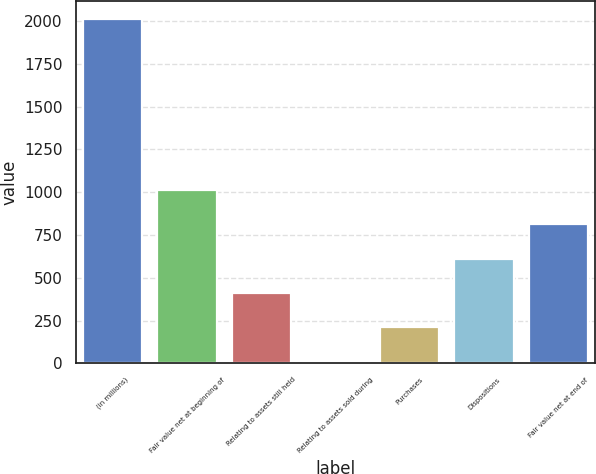Convert chart. <chart><loc_0><loc_0><loc_500><loc_500><bar_chart><fcel>(in millions)<fcel>Fair value net at beginning of<fcel>Relating to assets still held<fcel>Relating to assets sold during<fcel>Purchases<fcel>Dispositions<fcel>Fair value net at end of<nl><fcel>2013<fcel>1011.5<fcel>410.6<fcel>10<fcel>210.3<fcel>610.9<fcel>811.2<nl></chart> 